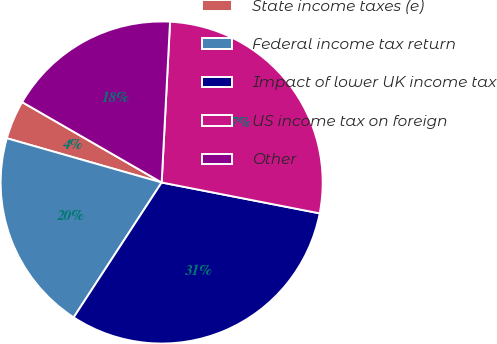Convert chart. <chart><loc_0><loc_0><loc_500><loc_500><pie_chart><fcel>State income taxes (e)<fcel>Federal income tax return<fcel>Impact of lower UK income tax<fcel>US income tax on foreign<fcel>Other<nl><fcel>3.89%<fcel>20.23%<fcel>31.13%<fcel>27.24%<fcel>17.51%<nl></chart> 